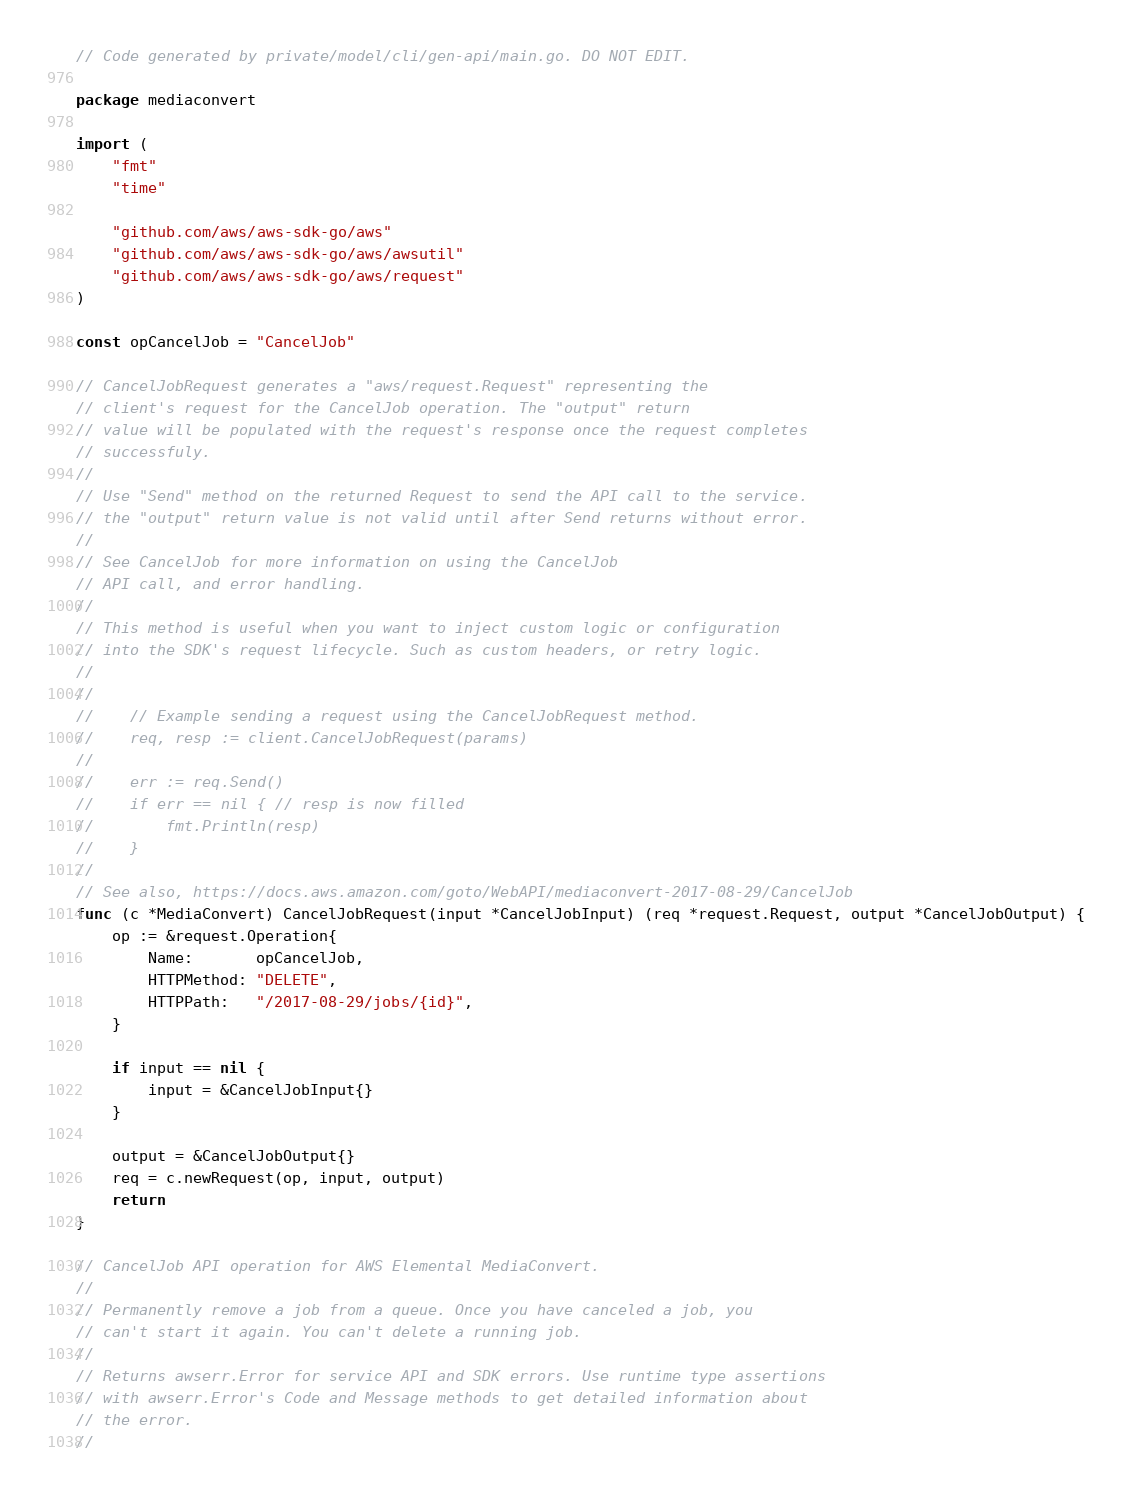<code> <loc_0><loc_0><loc_500><loc_500><_Go_>// Code generated by private/model/cli/gen-api/main.go. DO NOT EDIT.

package mediaconvert

import (
	"fmt"
	"time"

	"github.com/aws/aws-sdk-go/aws"
	"github.com/aws/aws-sdk-go/aws/awsutil"
	"github.com/aws/aws-sdk-go/aws/request"
)

const opCancelJob = "CancelJob"

// CancelJobRequest generates a "aws/request.Request" representing the
// client's request for the CancelJob operation. The "output" return
// value will be populated with the request's response once the request completes
// successfuly.
//
// Use "Send" method on the returned Request to send the API call to the service.
// the "output" return value is not valid until after Send returns without error.
//
// See CancelJob for more information on using the CancelJob
// API call, and error handling.
//
// This method is useful when you want to inject custom logic or configuration
// into the SDK's request lifecycle. Such as custom headers, or retry logic.
//
//
//    // Example sending a request using the CancelJobRequest method.
//    req, resp := client.CancelJobRequest(params)
//
//    err := req.Send()
//    if err == nil { // resp is now filled
//        fmt.Println(resp)
//    }
//
// See also, https://docs.aws.amazon.com/goto/WebAPI/mediaconvert-2017-08-29/CancelJob
func (c *MediaConvert) CancelJobRequest(input *CancelJobInput) (req *request.Request, output *CancelJobOutput) {
	op := &request.Operation{
		Name:       opCancelJob,
		HTTPMethod: "DELETE",
		HTTPPath:   "/2017-08-29/jobs/{id}",
	}

	if input == nil {
		input = &CancelJobInput{}
	}

	output = &CancelJobOutput{}
	req = c.newRequest(op, input, output)
	return
}

// CancelJob API operation for AWS Elemental MediaConvert.
//
// Permanently remove a job from a queue. Once you have canceled a job, you
// can't start it again. You can't delete a running job.
//
// Returns awserr.Error for service API and SDK errors. Use runtime type assertions
// with awserr.Error's Code and Message methods to get detailed information about
// the error.
//</code> 